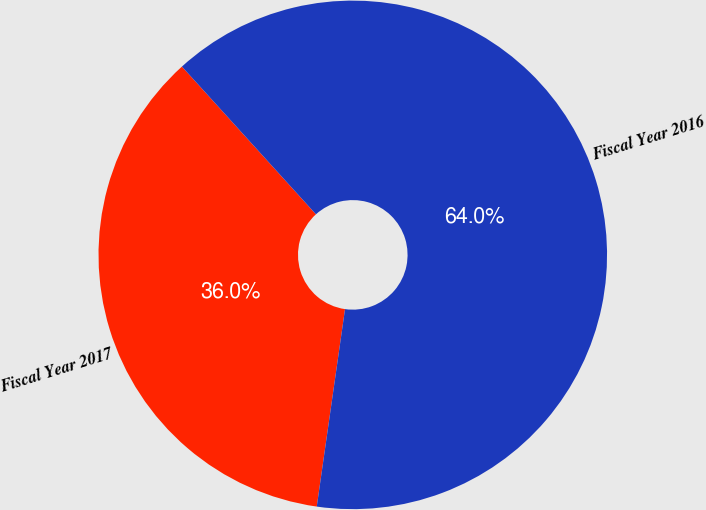Convert chart. <chart><loc_0><loc_0><loc_500><loc_500><pie_chart><fcel>Fiscal Year 2017<fcel>Fiscal Year 2016<nl><fcel>36.01%<fcel>63.99%<nl></chart> 